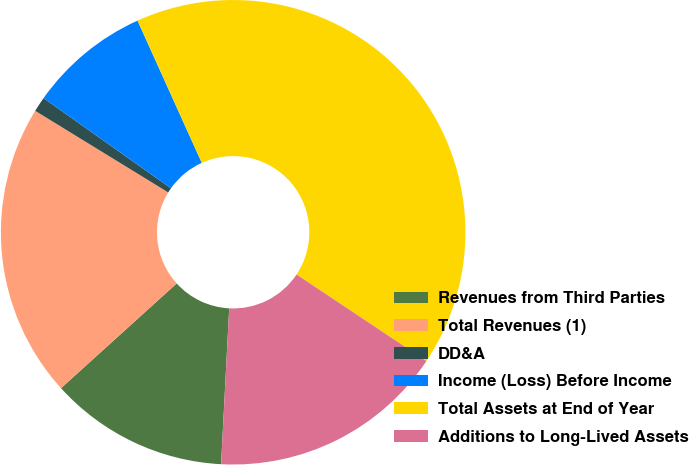Convert chart to OTSL. <chart><loc_0><loc_0><loc_500><loc_500><pie_chart><fcel>Revenues from Third Parties<fcel>Total Revenues (1)<fcel>DD&A<fcel>Income (Loss) Before Income<fcel>Total Assets at End of Year<fcel>Additions to Long-Lived Assets<nl><fcel>12.46%<fcel>20.47%<fcel>1.04%<fcel>8.45%<fcel>41.11%<fcel>16.47%<nl></chart> 